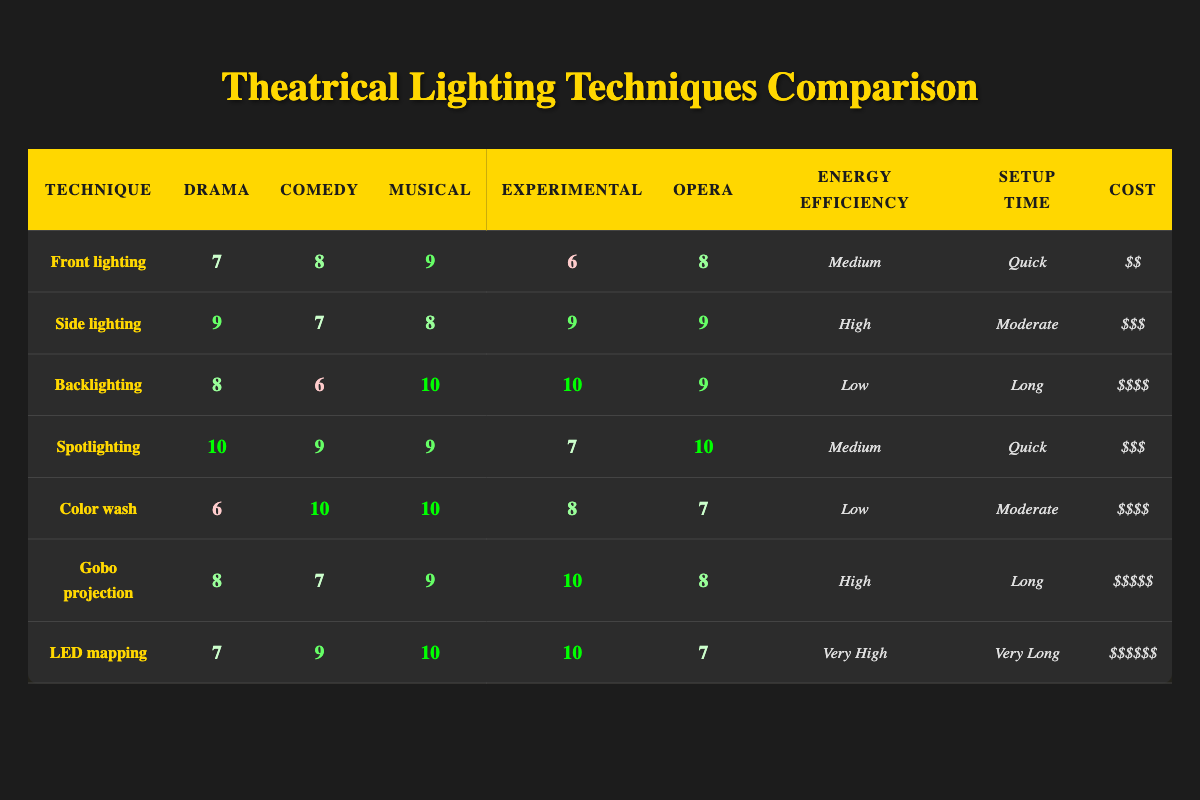What is the rating for the side lighting technique in drama? The rating for side lighting under the drama category can be found in the table. It shows a value of 9.
Answer: 9 Which lighting technique is rated the highest for musical performances? By examining the musical ratings in the table, backlighting, spotlighting, and LED mapping all scored 10, making them the highest-rated techniques for musicals.
Answer: Backlighting, spotlighting, LED mapping What is the cost of the most expensive lighting technique? Looking at the costs listed in the table, LED mapping is marked with the highest cost category of "$$$$$$".
Answer: $$$$$$ Which technique has the quickest setup time? A quick glance at the setup times indicates that both front lighting and spotlighting have a setup time labeled as "Quick".
Answer: Front lighting, spotlighting Calculate the average rating for the comedy genre across all techniques. To find the average, sum the ratings for comedy (8, 7, 6, 9, 10, 7, 9) which equals 66, then divide by the number of techniques (7), resulting in an average of 66/7, approximately 9.43.
Answer: 9.43 Is backlighting considered energy efficient? According to the table, backlighting has a labeled energy efficiency of "Low," indicating it is not considered energy efficient.
Answer: No What is the setup time for gobo projection technique? The setup time for gobo projection can be found in the corresponding row of the table, which states "Long."
Answer: Long Which lighting technique has the highest rating in the experimental category? The ratings for experimental are (6, 9, 10, 7, 8, 10, 10) and the maximum rating here is 10, which is achieved by both backlighting as well as LED mapping.
Answer: Backlighting, LED mapping Does the cost increase as the energy efficiency improves in the table? Evaluating the table shows that as energy efficiency increases from "Low" to "Medium" and "High," there is a rise in cost, but it does not follow a consistent pattern as seen with gobo projection and LED mapping which are expensive but offer high efficiency.
Answer: No 